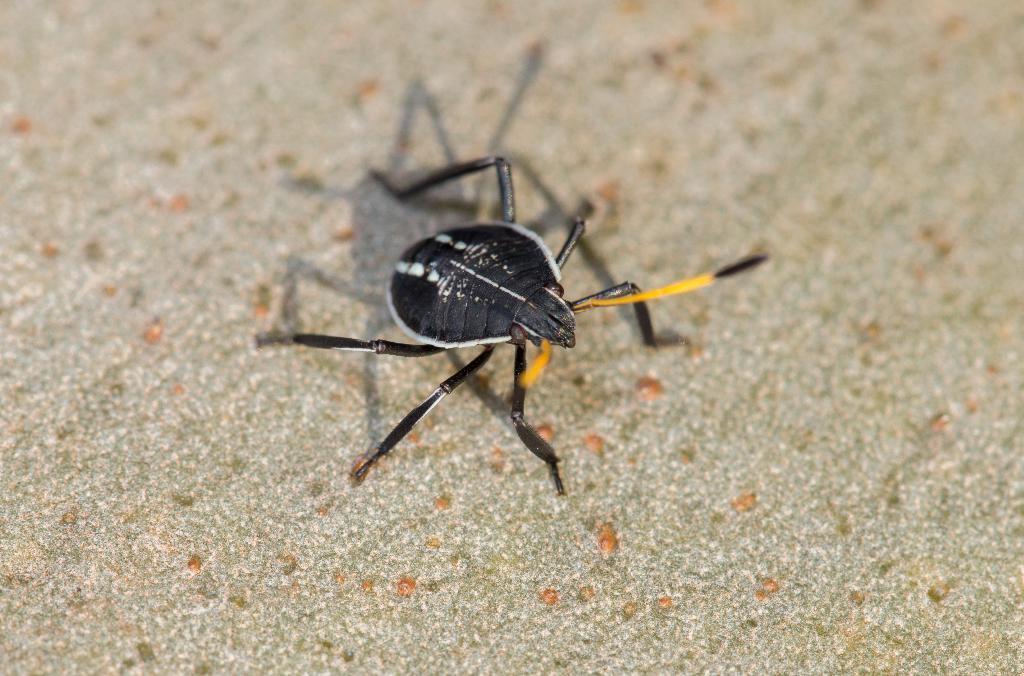Please provide a concise description of this image. In the center of the image an insect is present. 